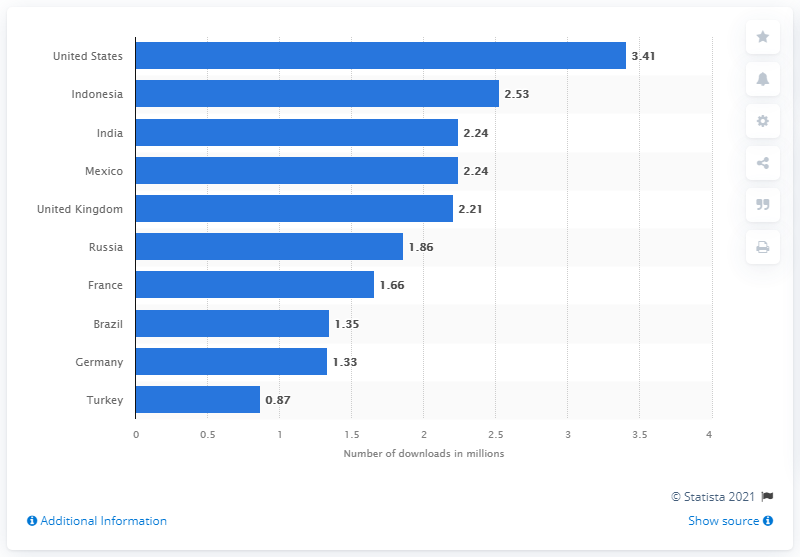Identify some key points in this picture. In the first quarter of 2021, iOS users downloads of WhatsApp were 3.41 billion. 